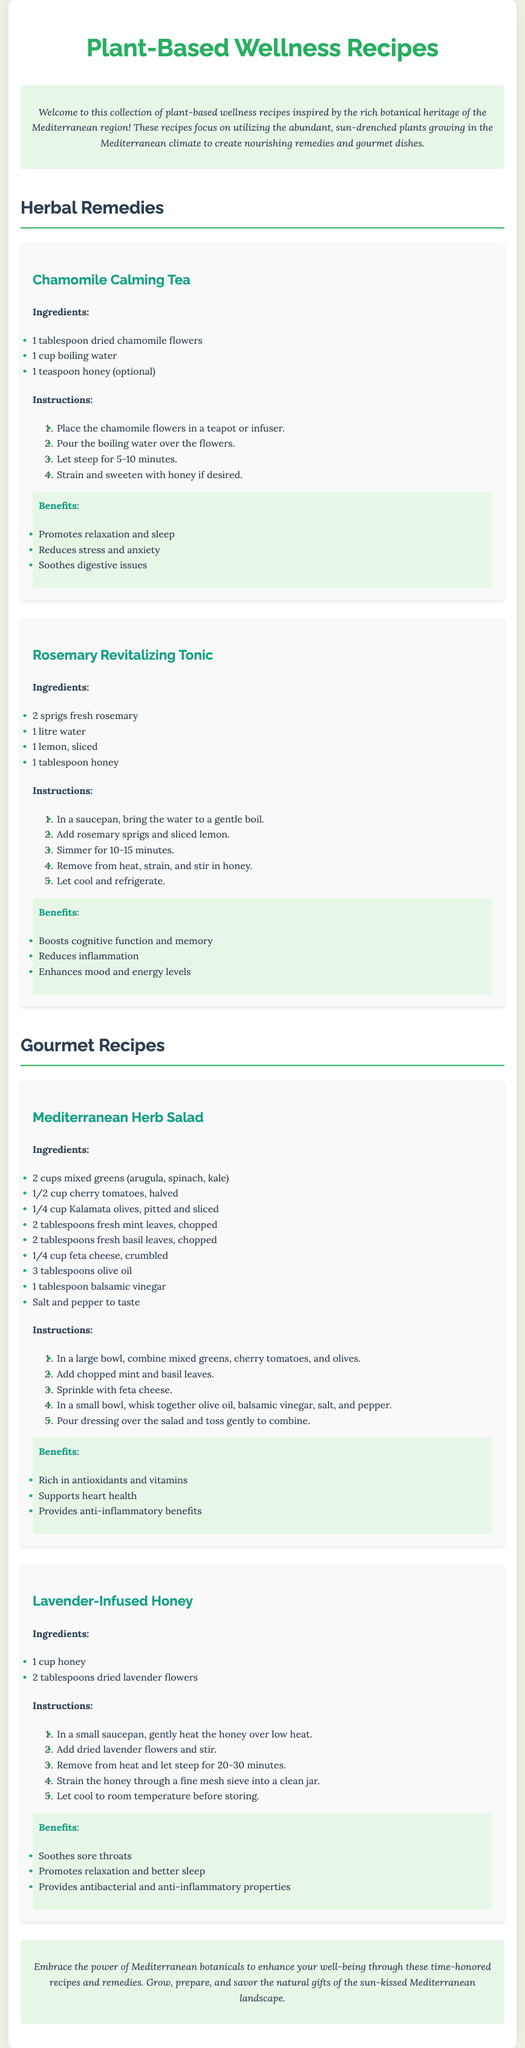What is the first recipe listed? The first recipe listed in the document is "Chamomile Calming Tea."
Answer: Chamomile Calming Tea How many ingredients are in the Mediterranean Herb Salad recipe? The Mediterranean Herb Salad recipe includes 9 ingredients listed.
Answer: 9 ingredients What is one benefit of the Lavender-Infused Honey? One of the benefits of Lavender-Infused Honey is that it soothes sore throats.
Answer: Soothes sore throats What herb is used in the Revitalizing Tonic? The herb used in the Rosemary Revitalizing Tonic is rosemary.
Answer: Rosemary How long should the Chamomile Calming Tea steep? The Chamomile Calming Tea should steep for 5-10 minutes.
Answer: 5-10 minutes What type of document is this? The document is a prescription for plant-based wellness recipes.
Answer: Prescription What herbal benefit relates to cognitive function? The benefit that relates to cognitive function is boosting memory.
Answer: Boosting memory How many times is honey mentioned in the document? Honey is mentioned four times in different recipes.
Answer: Four times 